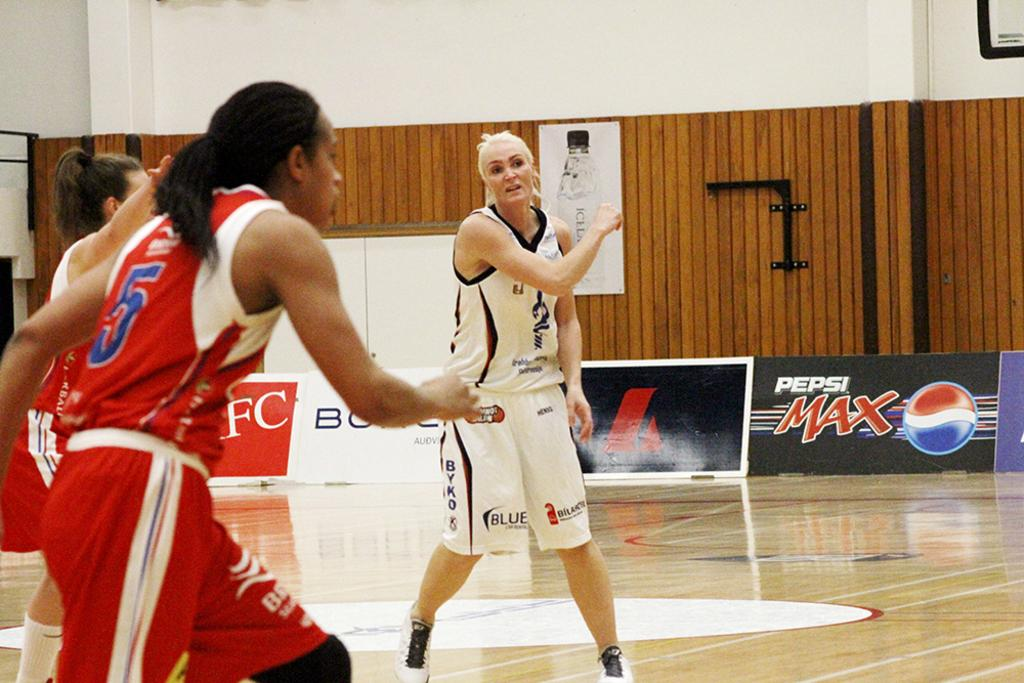<image>
Render a clear and concise summary of the photo. Women play basketball in front of an advertisement for Pepsi Max 